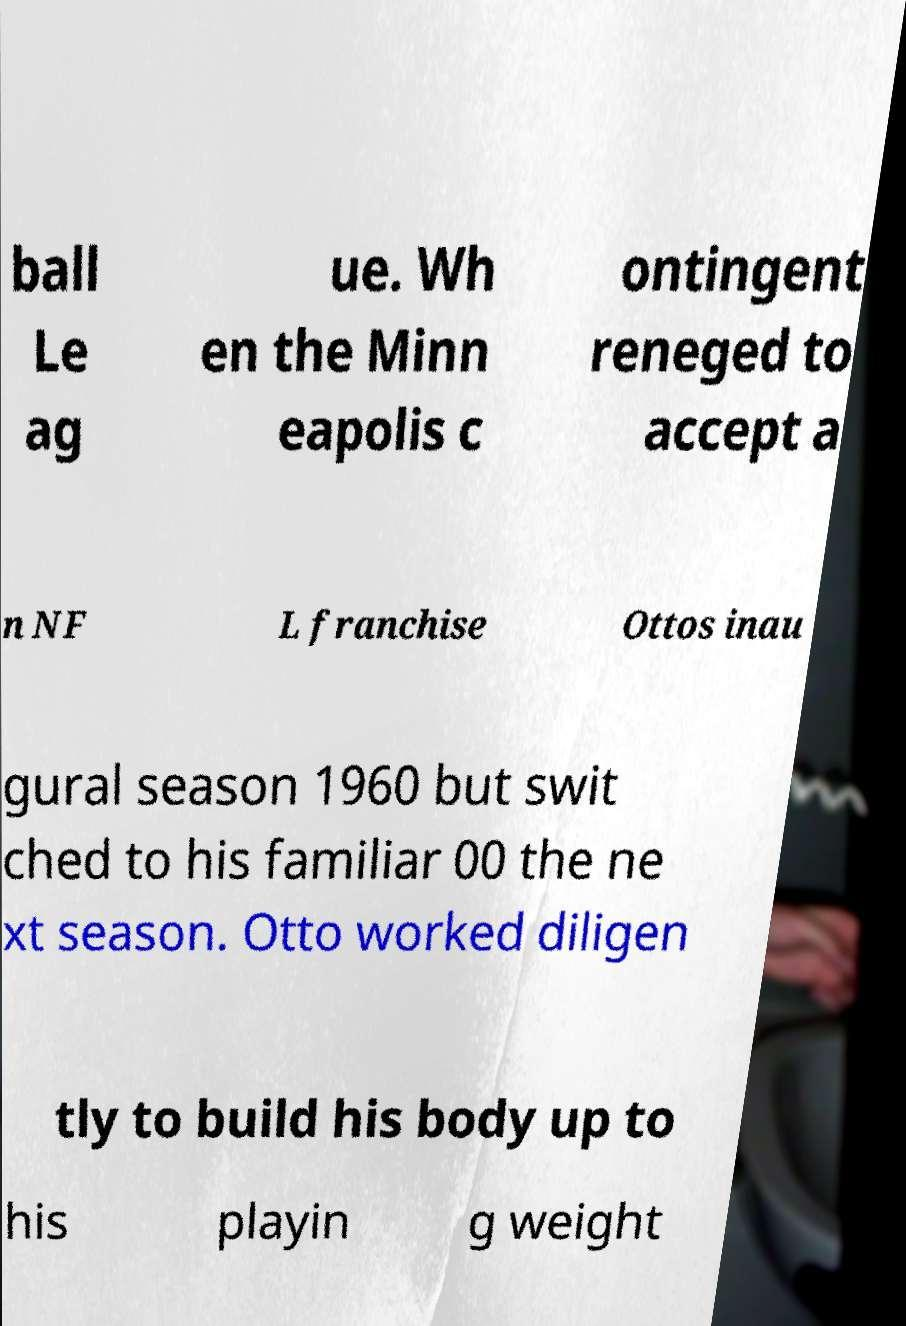There's text embedded in this image that I need extracted. Can you transcribe it verbatim? ball Le ag ue. Wh en the Minn eapolis c ontingent reneged to accept a n NF L franchise Ottos inau gural season 1960 but swit ched to his familiar 00 the ne xt season. Otto worked diligen tly to build his body up to his playin g weight 